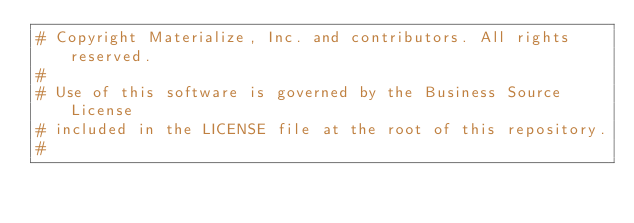<code> <loc_0><loc_0><loc_500><loc_500><_Dockerfile_># Copyright Materialize, Inc. and contributors. All rights reserved.
#
# Use of this software is governed by the Business Source License
# included in the LICENSE file at the root of this repository.
#</code> 